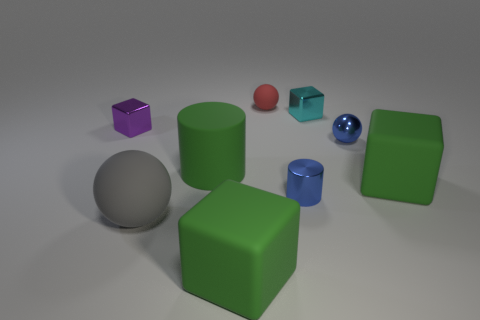What color is the rubber ball in front of the metal cube to the left of the matte cube left of the blue metallic sphere?
Offer a very short reply. Gray. What shape is the cyan shiny thing that is the same size as the red matte object?
Your answer should be compact. Cube. There is a green cylinder on the right side of the big gray ball; does it have the same size as the ball that is behind the metal ball?
Your response must be concise. No. What is the size of the green block behind the big gray matte sphere?
Make the answer very short. Large. The metal cylinder that is the same size as the purple object is what color?
Give a very brief answer. Blue. Do the cyan shiny block and the gray ball have the same size?
Provide a short and direct response. No. There is a thing that is behind the big ball and on the left side of the matte cylinder; how big is it?
Ensure brevity in your answer.  Small. What number of shiny objects are big green objects or purple objects?
Your response must be concise. 1. Are there more metal balls left of the rubber cylinder than tiny purple shiny cubes?
Your answer should be compact. No. What is the large thing on the right side of the red object made of?
Keep it short and to the point. Rubber. 